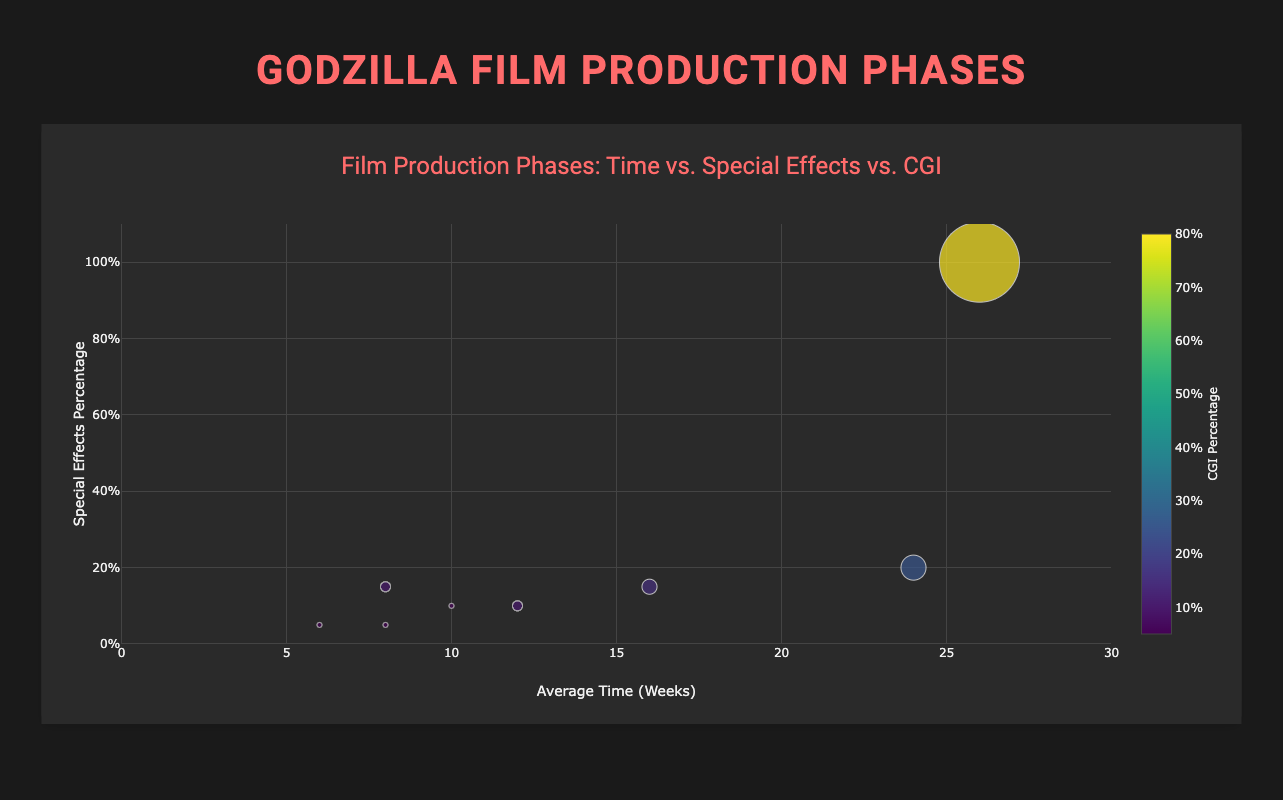What is the title of the Bubble Chart? The title of the Bubble Chart is displayed at the top and it reads "Film Production Phases: Time vs. Special Effects vs. CGI".
Answer: Film Production Phases: Time vs. Special Effects vs. CGI Which phase has the highest percentage of special effects? By looking at the y-axis, which represents special effects percentage, and locating the highest data point, we see that "Visual Effects" phase has the highest percentage of special effects at 100%.
Answer: Visual Effects How long is the average time spent on Visual Effects compared to Scriptwriting? The average time for Visual Effects is 26 weeks, and for Scriptwriting, it is 8 weeks. Subtracting these values (26 - 8) gives a difference of 18 weeks.
Answer: 18 weeks If you double the CGI percentage of the Scriptwriting phase, how does it compare to the CGI percentage of the Sound Editing phase? Scriptwriting has 5% CGI. Doubling this gives 10%. The Sound Editing phase has 5% CGI. Both phases then have the same 10% CGI.
Answer: The same Which phase has the largest bubble and what does it represent? The bubble size represents the CGI percentage. The largest bubble corresponds to the "Visual Effects" phase which has the highest CGI percentage of 80%.
Answer: Visual Effects What is the median value of average time spent across all phases? The sorted average times are 6, 8, 8, 10, 12, 16, 24, 26 weeks. The median value is calculated by taking the average of the middle two numbers (12 and 16), resulting in (12 + 16)/2 = 14 weeks.
Answer: 14 weeks Which two phases have the same special effects percentage and what is it? By examining the y-axis and locating the data points, we see that "Scriptwriting" and "Final Cut" both have a special effects percentage of 5%.
Answer: Scriptwriting and Final Cut, 5% How does the special effects percentage in Principal Photography compare to that in Pre-production? Principal Photography has a special effects percentage of 15% while Pre-production has 10%. Comparing the two, Principal Photography has 5% more special effects.
Answer: 5% more What's the average CGI percentage in phases with more than 10 weeks of average time? Phases with more than 10 weeks are Pre-production (10%), Principal Photography (15%), Post-production (25%), and Visual Effects (80%). Their CGI percentages are (10 + 15 + 25 + 80) = 130, and since there are 4 phases, the average is 130/4 = 32.5%.
Answer: 32.5% What is the color scheme used to represent the CGI percentage on the bubbles? The colors of the bubbles are mapped using the 'Viridis' color scale, with a color gradient reflecting different CGI percentages.
Answer: Viridis 